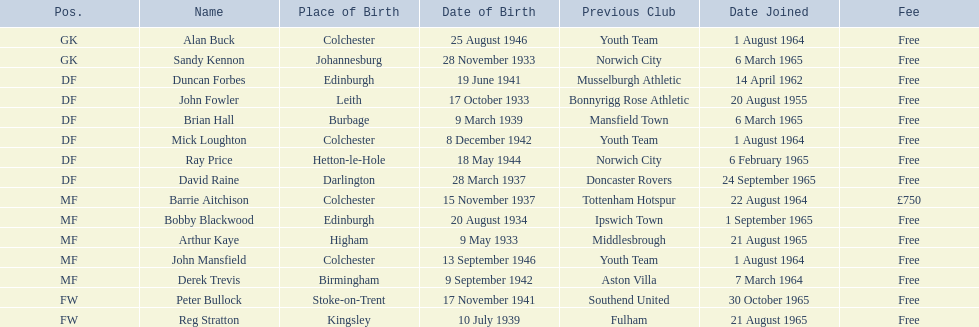On which date did the first player join? 20 August 1955. Could you parse the entire table as a dict? {'header': ['Pos.', 'Name', 'Place of Birth', 'Date of Birth', 'Previous Club', 'Date Joined', 'Fee'], 'rows': [['GK', 'Alan Buck', 'Colchester', '25 August 1946', 'Youth Team', '1 August 1964', 'Free'], ['GK', 'Sandy Kennon', 'Johannesburg', '28 November 1933', 'Norwich City', '6 March 1965', 'Free'], ['DF', 'Duncan Forbes', 'Edinburgh', '19 June 1941', 'Musselburgh Athletic', '14 April 1962', 'Free'], ['DF', 'John Fowler', 'Leith', '17 October 1933', 'Bonnyrigg Rose Athletic', '20 August 1955', 'Free'], ['DF', 'Brian Hall', 'Burbage', '9 March 1939', 'Mansfield Town', '6 March 1965', 'Free'], ['DF', 'Mick Loughton', 'Colchester', '8 December 1942', 'Youth Team', '1 August 1964', 'Free'], ['DF', 'Ray Price', 'Hetton-le-Hole', '18 May 1944', 'Norwich City', '6 February 1965', 'Free'], ['DF', 'David Raine', 'Darlington', '28 March 1937', 'Doncaster Rovers', '24 September 1965', 'Free'], ['MF', 'Barrie Aitchison', 'Colchester', '15 November 1937', 'Tottenham Hotspur', '22 August 1964', '£750'], ['MF', 'Bobby Blackwood', 'Edinburgh', '20 August 1934', 'Ipswich Town', '1 September 1965', 'Free'], ['MF', 'Arthur Kaye', 'Higham', '9 May 1933', 'Middlesbrough', '21 August 1965', 'Free'], ['MF', 'John Mansfield', 'Colchester', '13 September 1946', 'Youth Team', '1 August 1964', 'Free'], ['MF', 'Derek Trevis', 'Birmingham', '9 September 1942', 'Aston Villa', '7 March 1964', 'Free'], ['FW', 'Peter Bullock', 'Stoke-on-Trent', '17 November 1941', 'Southend United', '30 October 1965', 'Free'], ['FW', 'Reg Stratton', 'Kingsley', '10 July 1939', 'Fulham', '21 August 1965', 'Free']]} 